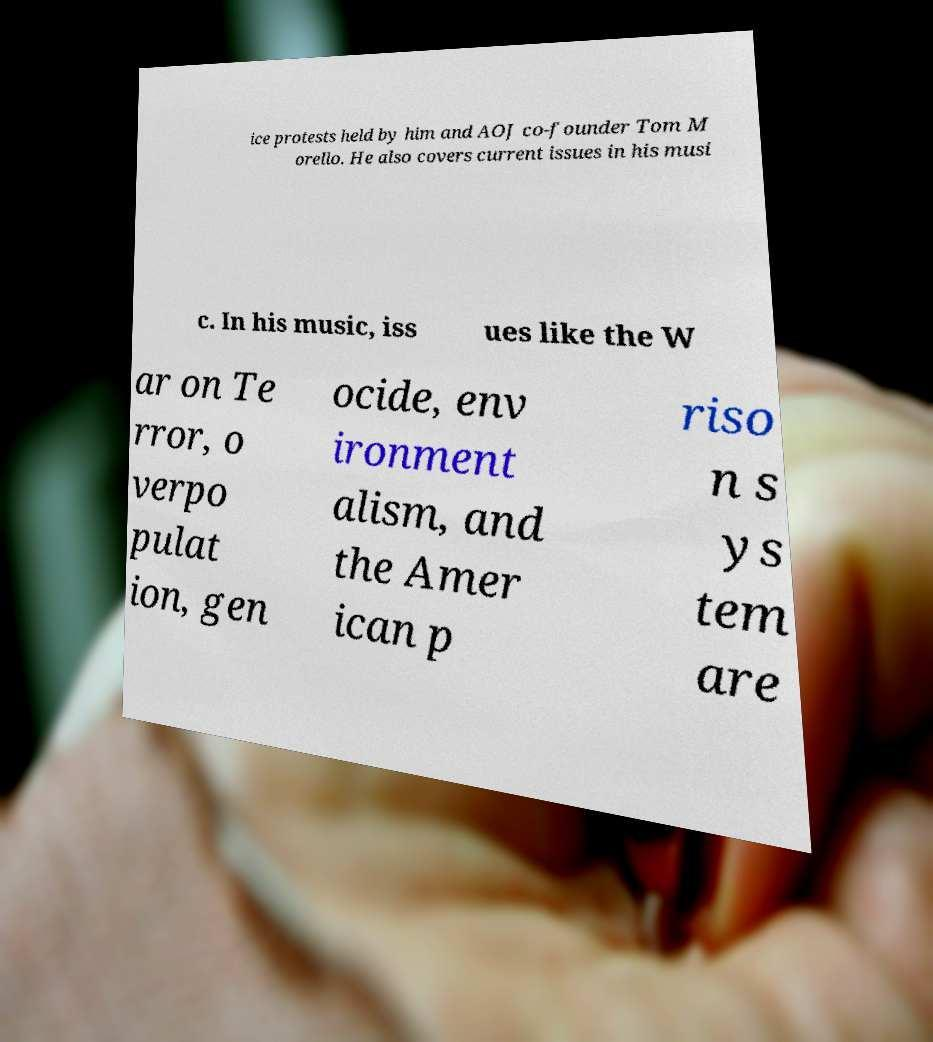There's text embedded in this image that I need extracted. Can you transcribe it verbatim? ice protests held by him and AOJ co-founder Tom M orello. He also covers current issues in his musi c. In his music, iss ues like the W ar on Te rror, o verpo pulat ion, gen ocide, env ironment alism, and the Amer ican p riso n s ys tem are 